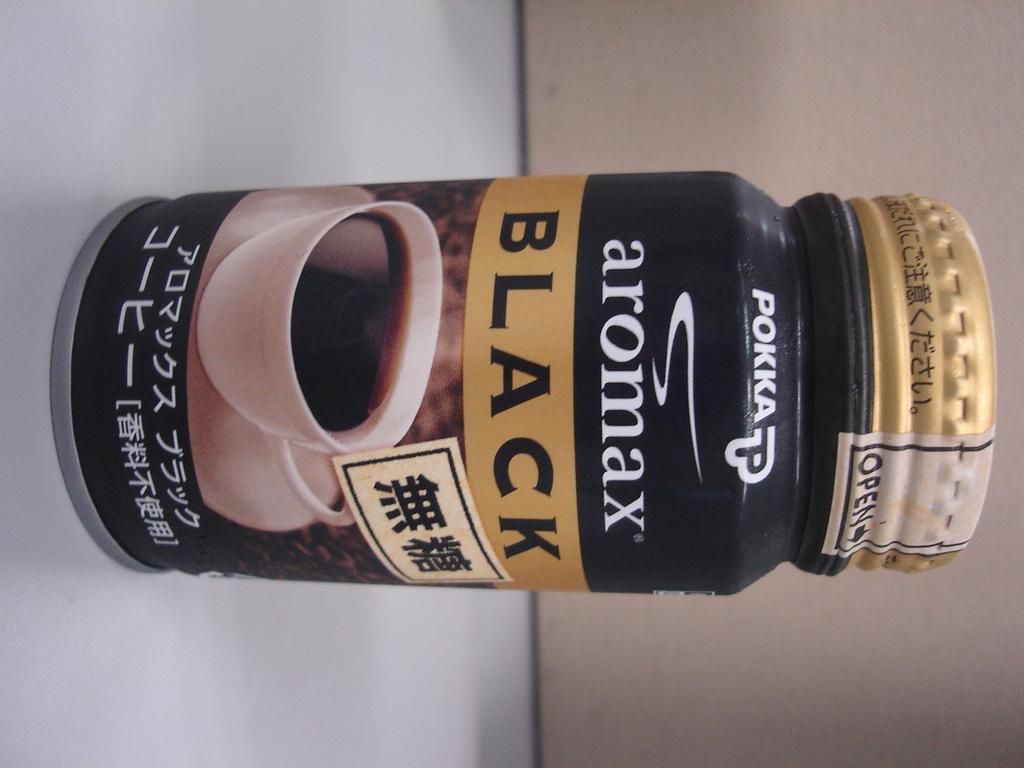What is the brand of the coffee?
Give a very brief answer. Pokka. What company is shown?
Your response must be concise. Pokka. 